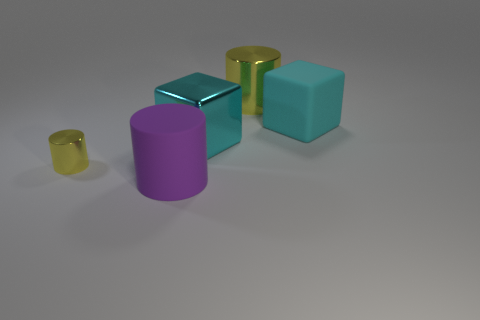How does the lighting in this image affect the appearance of the objects? The lighting in the image creates soft shadows and emphasizes the textures of each item. The metallic and glass objects have highlighted edges and reflect light, which accentuates their shiny properties. Meanwhile, the matte surfaces of the plastic objects absorb more light, resulting in a flatter appearance with softer, less defined shadows. 